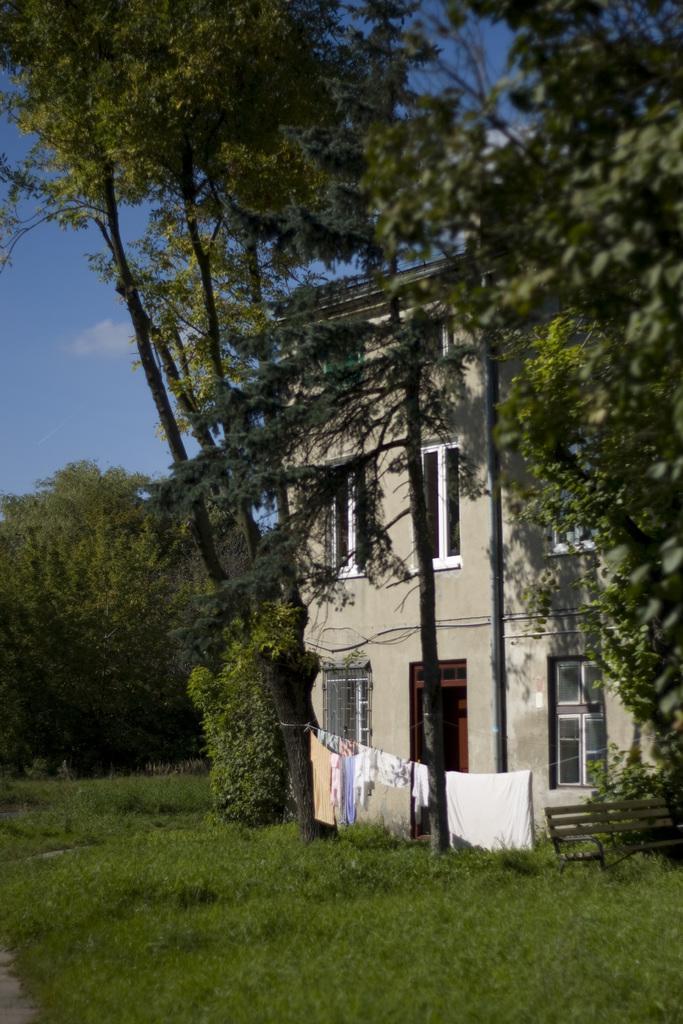Please provide a concise description of this image. This picture is clicked outside. In the foreground we can see the green grass and the clothes hanging on the rope and we can see the bench, plants, trees and a house and we can see the windows of the house. In the background we can see the sky. 